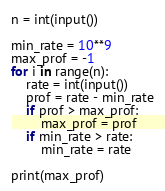Convert code to text. <code><loc_0><loc_0><loc_500><loc_500><_Python_>n = int(input())

min_rate = 10**9
max_prof = -1
for i in range(n):
    rate = int(input())
    prof = rate - min_rate
    if prof > max_prof:
        max_prof = prof
    if min_rate > rate:
        min_rate = rate

print(max_prof)
</code> 